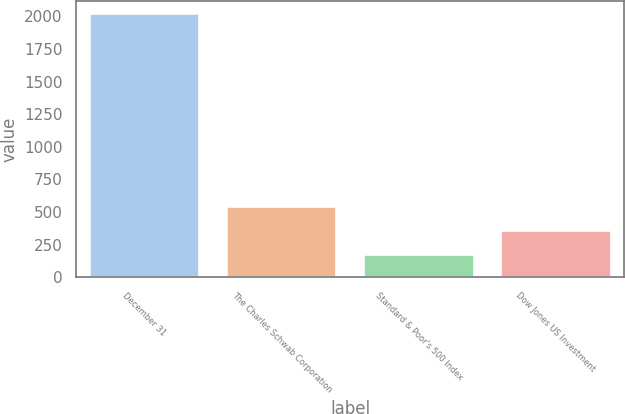Convert chart to OTSL. <chart><loc_0><loc_0><loc_500><loc_500><bar_chart><fcel>December 31<fcel>The Charles Schwab Corporation<fcel>Standard & Poor's 500 Index<fcel>Dow Jones US Investment<nl><fcel>2016<fcel>540<fcel>171<fcel>355.5<nl></chart> 